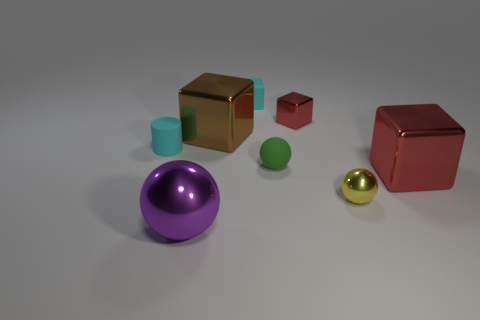Subtract all blue cylinders. How many red blocks are left? 2 Subtract all small yellow metal balls. How many balls are left? 2 Add 2 small cyan rubber cubes. How many objects exist? 10 Subtract all cyan cubes. How many cubes are left? 3 Subtract 1 balls. How many balls are left? 2 Subtract all brown spheres. Subtract all green cylinders. How many spheres are left? 3 Subtract all rubber spheres. Subtract all cyan rubber things. How many objects are left? 5 Add 1 tiny cyan matte things. How many tiny cyan matte things are left? 3 Add 2 matte spheres. How many matte spheres exist? 3 Subtract 1 purple balls. How many objects are left? 7 